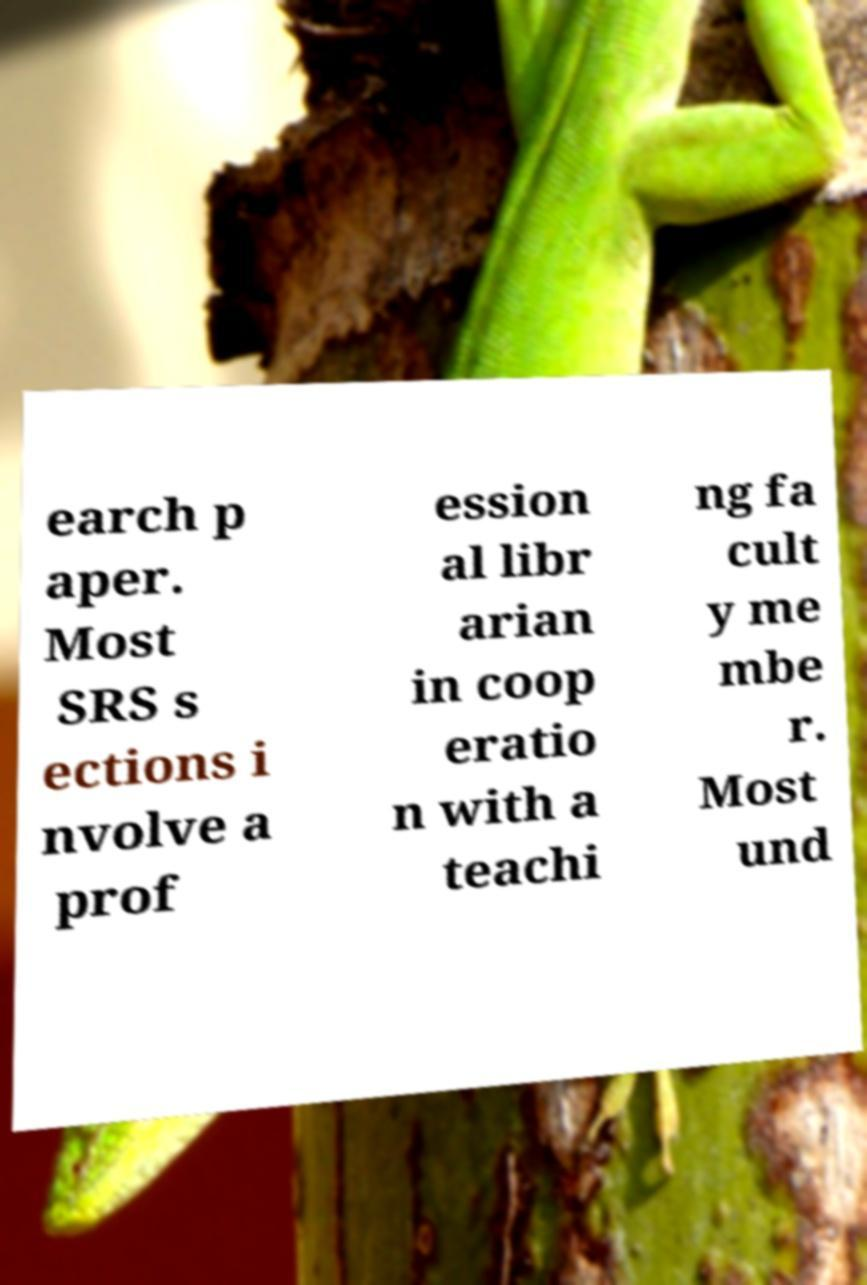Can you accurately transcribe the text from the provided image for me? earch p aper. Most SRS s ections i nvolve a prof ession al libr arian in coop eratio n with a teachi ng fa cult y me mbe r. Most und 